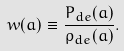<formula> <loc_0><loc_0><loc_500><loc_500>w ( a ) \equiv \frac { P _ { d e } ( a ) } { \rho _ { d e } ( a ) } .</formula> 